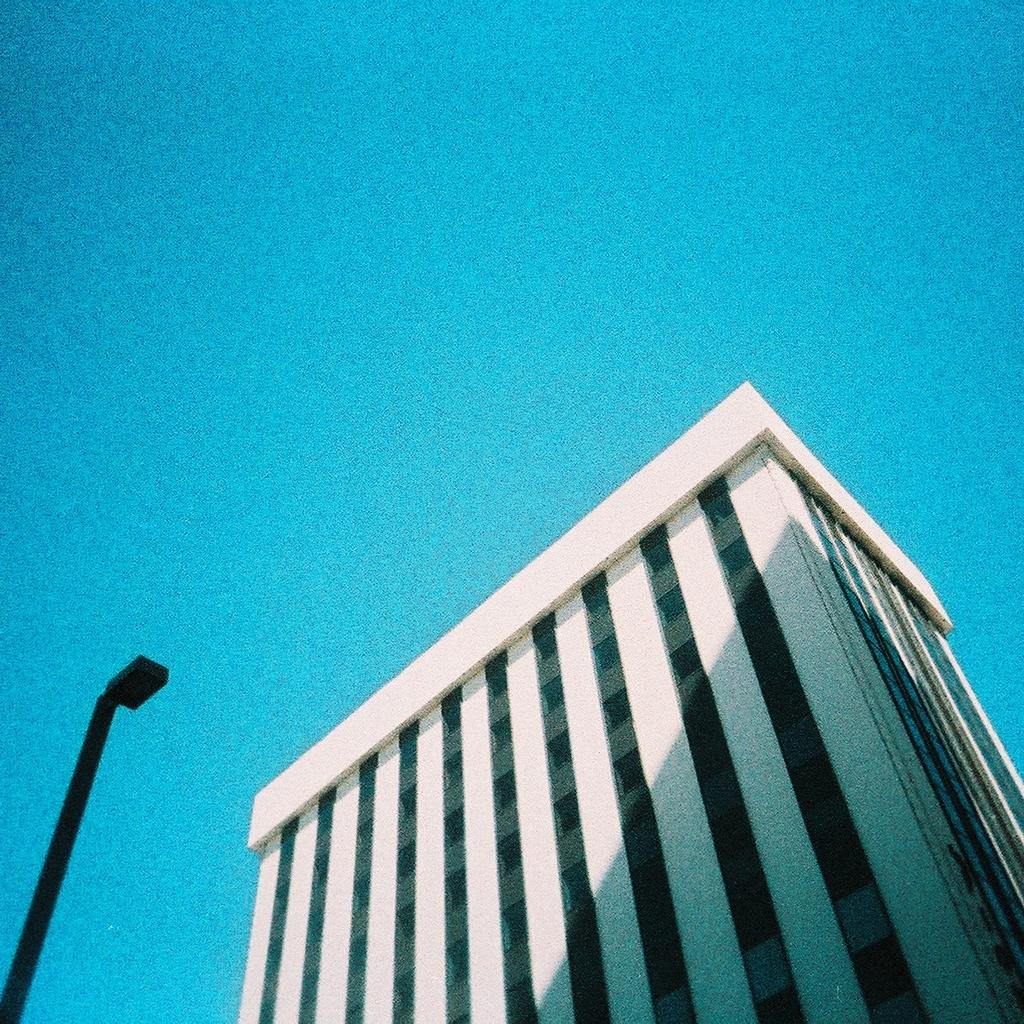What type of structure is in the image? There is a building in the image. Can you describe the color of the building? The building is white. What else can be seen in the image besides the building? There is a pole in the image. What is the color of the pole? The pole is black. What is visible at the top of the image? The sky is visible at the top of the image. What type of theory is being discussed in the image? There is no discussion or theory present in the image; it features a building, a black pole, and a visible sky. Are there any stockings visible in the image? There are no stockings present in the image. 